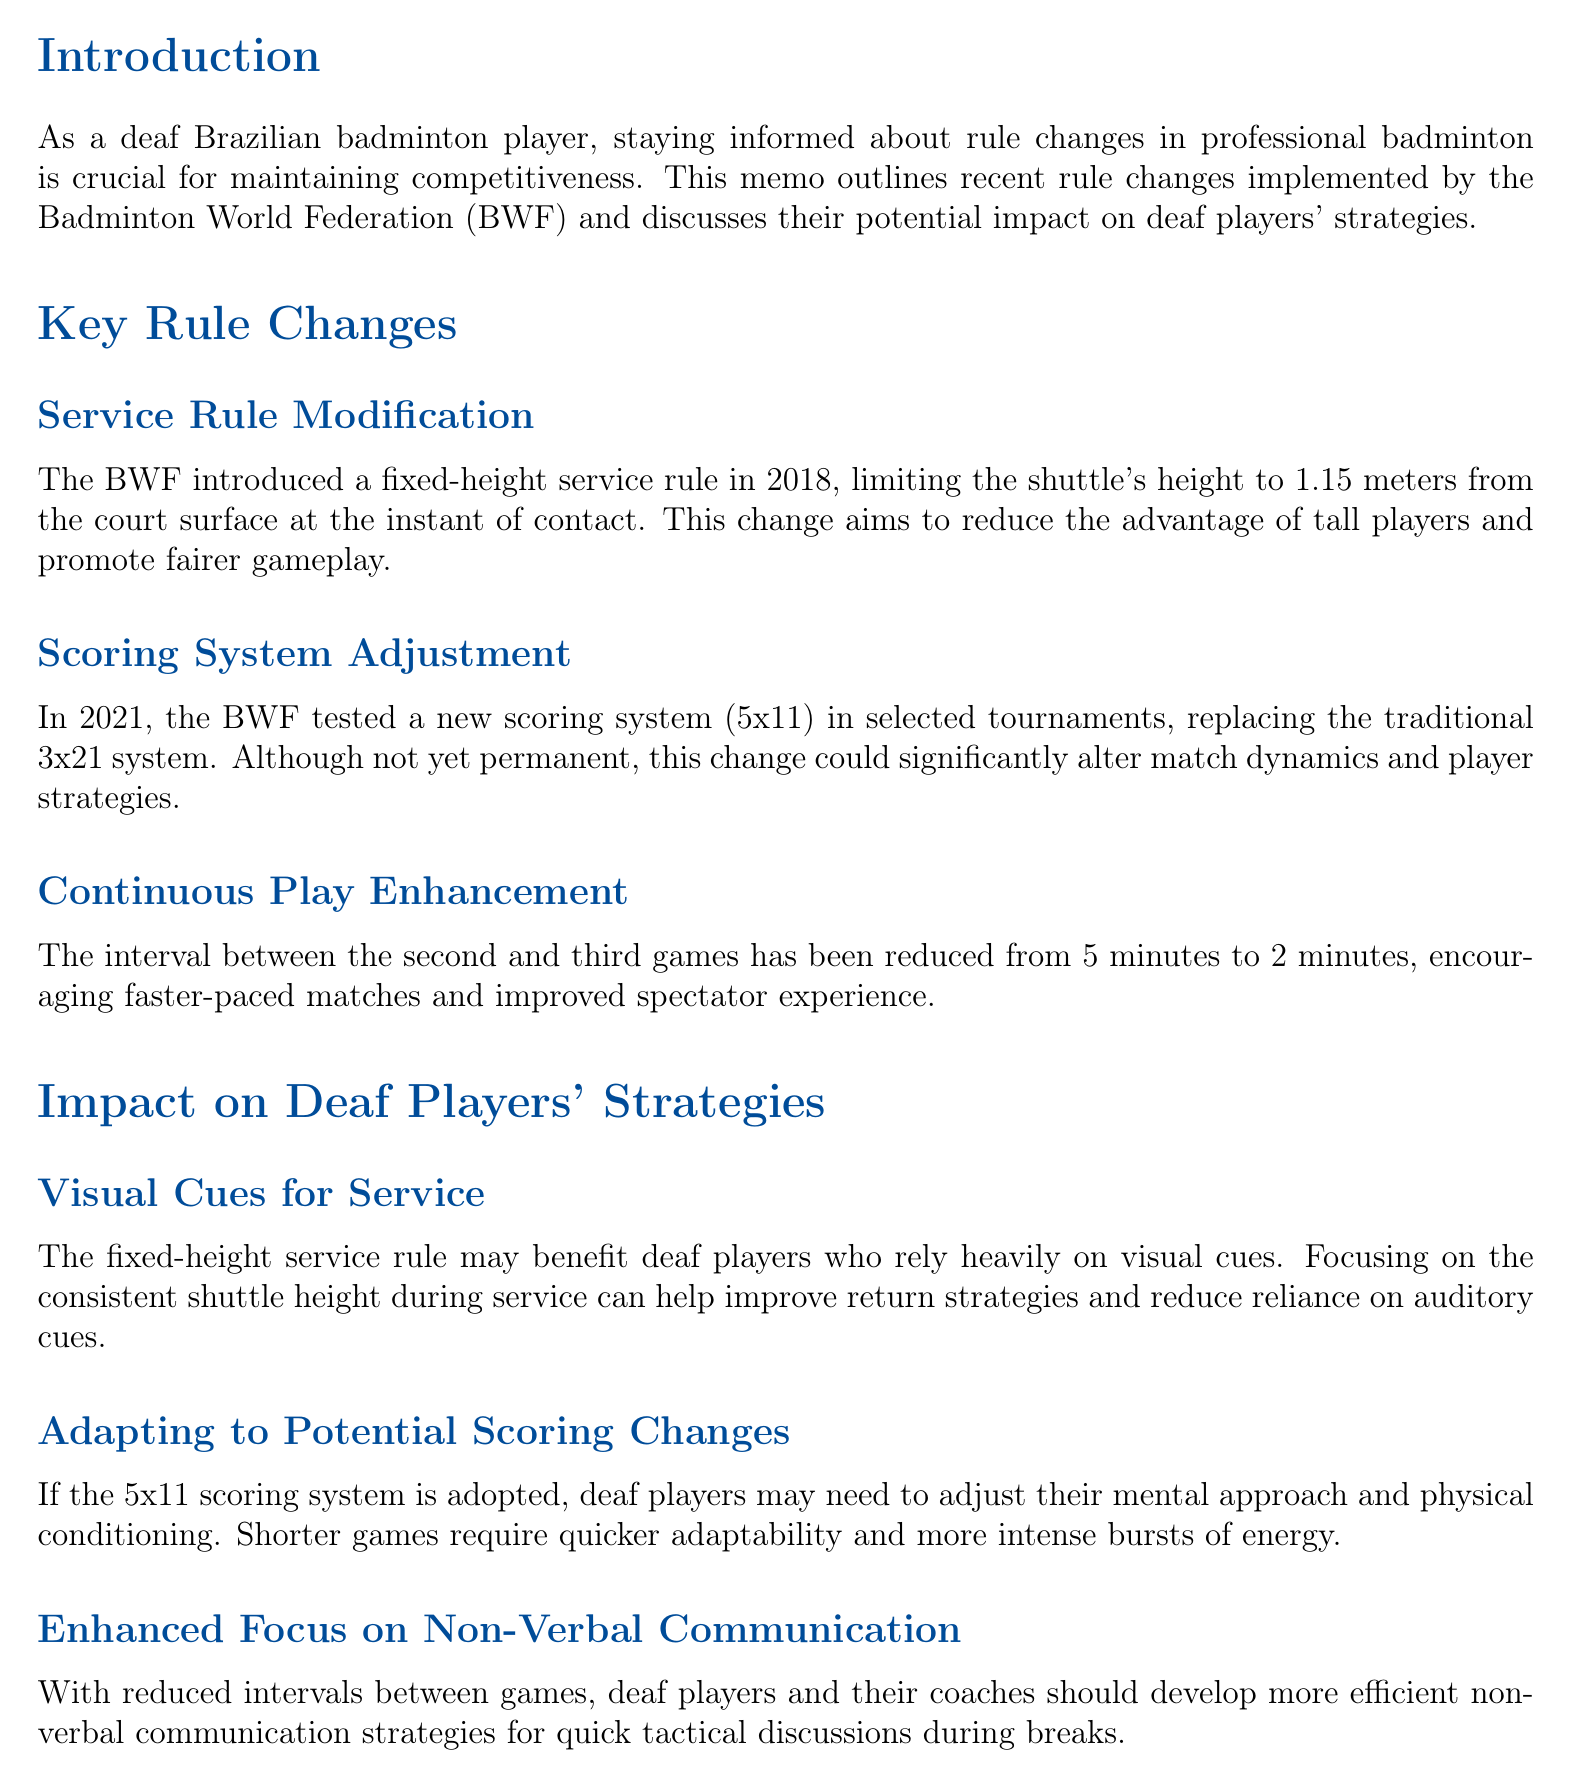what is the title of the document? The title provides a clear indication of the document's focus and is located at the top.
Answer: Recent Rule Changes in Professional Badminton and Their Impact on Deaf Players' Strategies who introduced the fixed-height service rule? The document attributes the introduction of the fixed-height service rule to the Badminton World Federation.
Answer: Badminton World Federation what is the height limit for the shuttle under the fixed-height service rule? The document specifies the height limit for the shuttle during service, which is vital for understanding this rule.
Answer: 1.15 meters what is the new interval duration between the second and third games? The document states the modified duration for the interval, which is significant for match pacing.
Answer: 2 minutes how might deaf players benefit from the fixed-height service rule? This question combines elements from the document, focusing on the implications of the rule change for deaf players.
Answer: Improve return strategies why might deaf players need to adapt their physical conditioning if the 5x11 scoring system is adopted? A deeper understanding of the match format change requires reasoning about its impact on players' fitness needs.
Answer: Shorter games require quicker adaptability what should deaf players develop to improve communication during reduced game intervals? This question highlights a strategy mentioned in the document relevant to deaf players adapting to new game conditions.
Answer: Non-verbal communication strategies what organization should players consult with regarding their strategies? The document suggests a specific organization that players can collaborate with to adapt effectively.
Answer: Confederação Brasileira de Badminton 